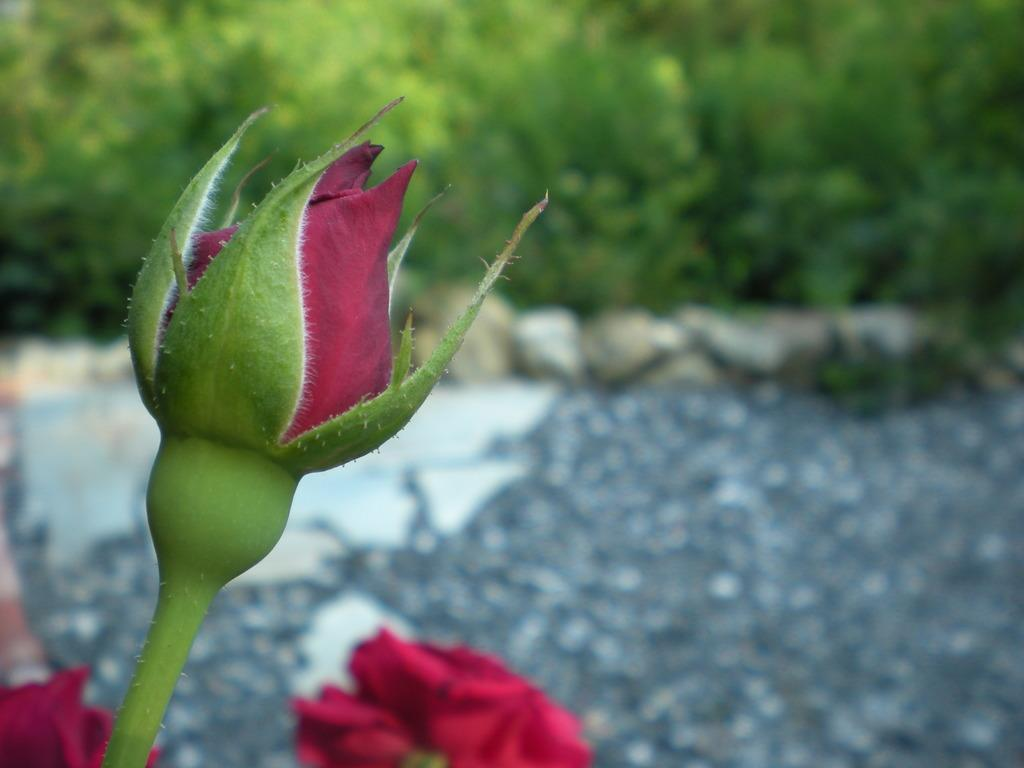What is the main subject in the center of the image? There are flowers in the center of the image. What color are the flowers? The flowers are red in color. What can be seen in the background of the image? There are trees and stones in the background of the image. Are there any other objects visible in the background? Yes, there are a few other objects in the background of the image. Can you tell me how many times the person made a request during the operation in the image? There is no person making requests or performing an operation in the image; it features flowers, trees, and stones. 